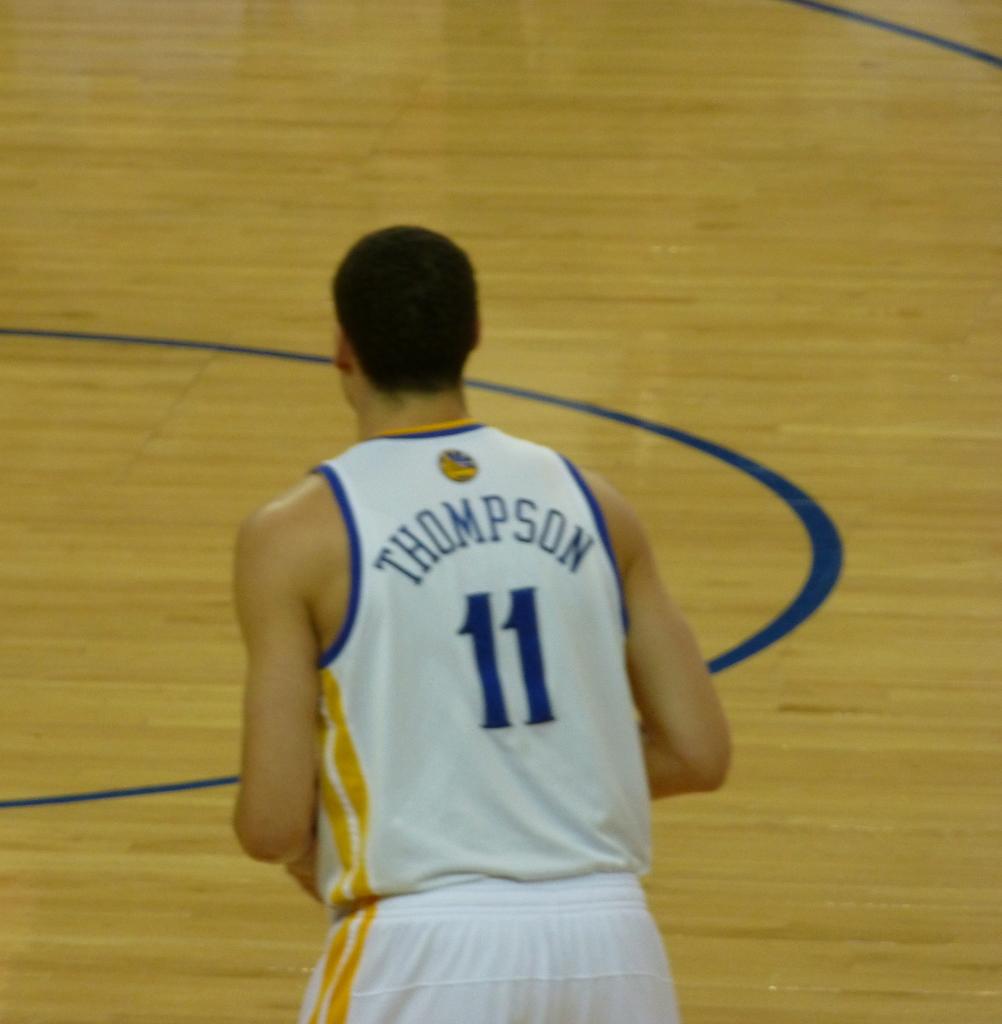What is the name of this three point shooter?
Keep it short and to the point. Thompson. What is the number on the back of the jersey?
Your answer should be compact. 11. 